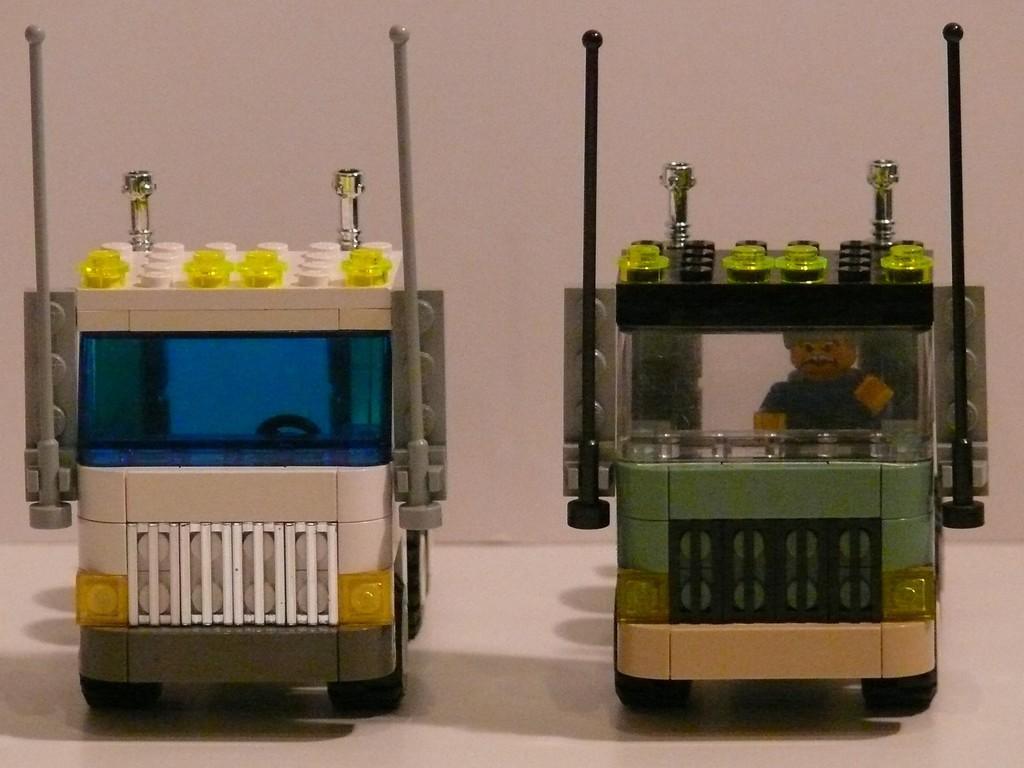Can you describe this image briefly? In this picture we can see the toys. At the bottom of the image we can see the floor. In the background of the image we can see the wall. 